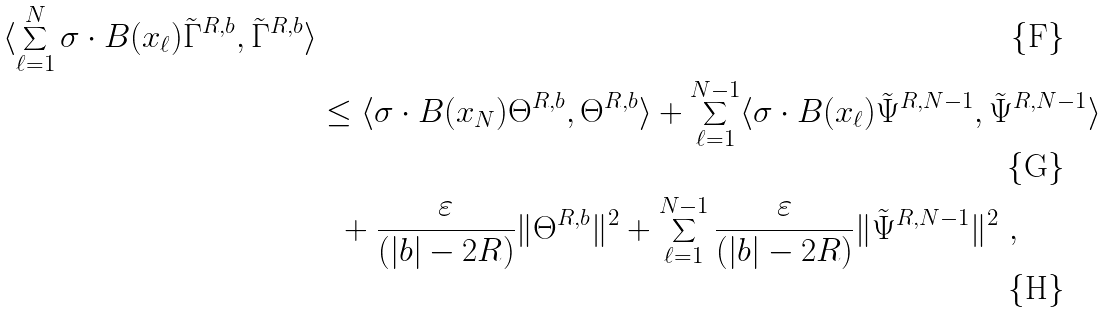Convert formula to latex. <formula><loc_0><loc_0><loc_500><loc_500>{ \langle \sum _ { \ell = 1 } ^ { N } \sigma \cdot B ( x _ { \ell } ) \tilde { \Gamma } ^ { R , b } , \tilde { \Gamma } ^ { R , b } \rangle } & \\ & \leq \langle \sigma \cdot B ( x _ { N } ) \Theta ^ { R , b } , \Theta ^ { R , b } \rangle + \sum _ { \ell = 1 } ^ { N - 1 } \langle \sigma \cdot B ( x _ { \ell } ) \tilde { \Psi } ^ { R , N - 1 } , \tilde { \Psi } ^ { R , N - 1 } \rangle \\ & \ \ + \frac { \varepsilon } { ( | b | - 2 R ) } \| \Theta ^ { R , b } \| ^ { 2 } + \sum _ { \ell = 1 } ^ { N - 1 } \frac { \varepsilon } { ( | b | - 2 R ) } \| \tilde { \Psi } ^ { R , N - 1 } \| ^ { 2 } \ ,</formula> 